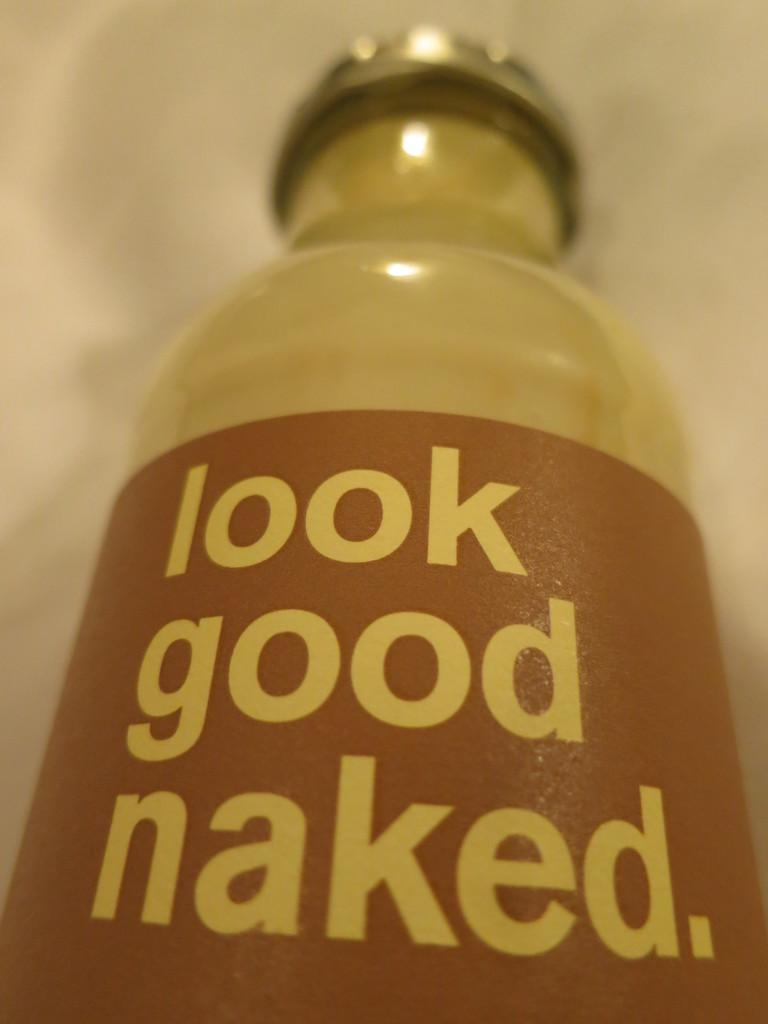<image>
Offer a succinct explanation of the picture presented. A bottle of liquid advertises that one should look good naked. 